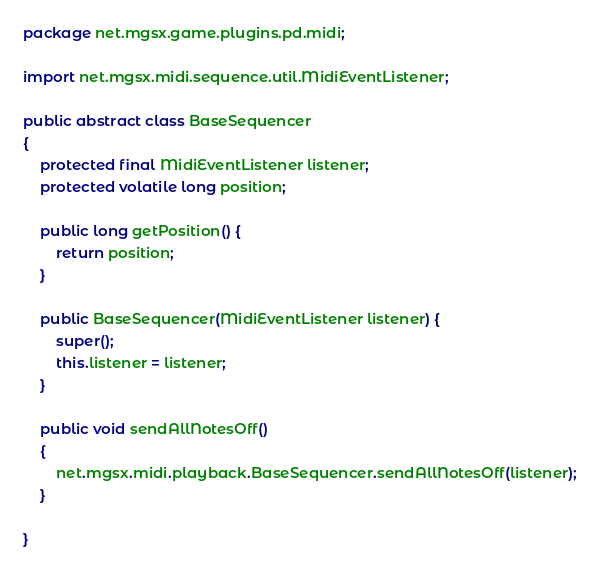<code> <loc_0><loc_0><loc_500><loc_500><_Java_>package net.mgsx.game.plugins.pd.midi;

import net.mgsx.midi.sequence.util.MidiEventListener;

public abstract class BaseSequencer
{
	protected final MidiEventListener listener;
	protected volatile long position;

	public long getPosition() {
		return position;
	}

	public BaseSequencer(MidiEventListener listener) {
		super();
		this.listener = listener;
	}

	public void sendAllNotesOff()
	{
		net.mgsx.midi.playback.BaseSequencer.sendAllNotesOff(listener);
	}
	
}
</code> 